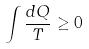Convert formula to latex. <formula><loc_0><loc_0><loc_500><loc_500>\int \frac { d Q } { T } \geq 0</formula> 